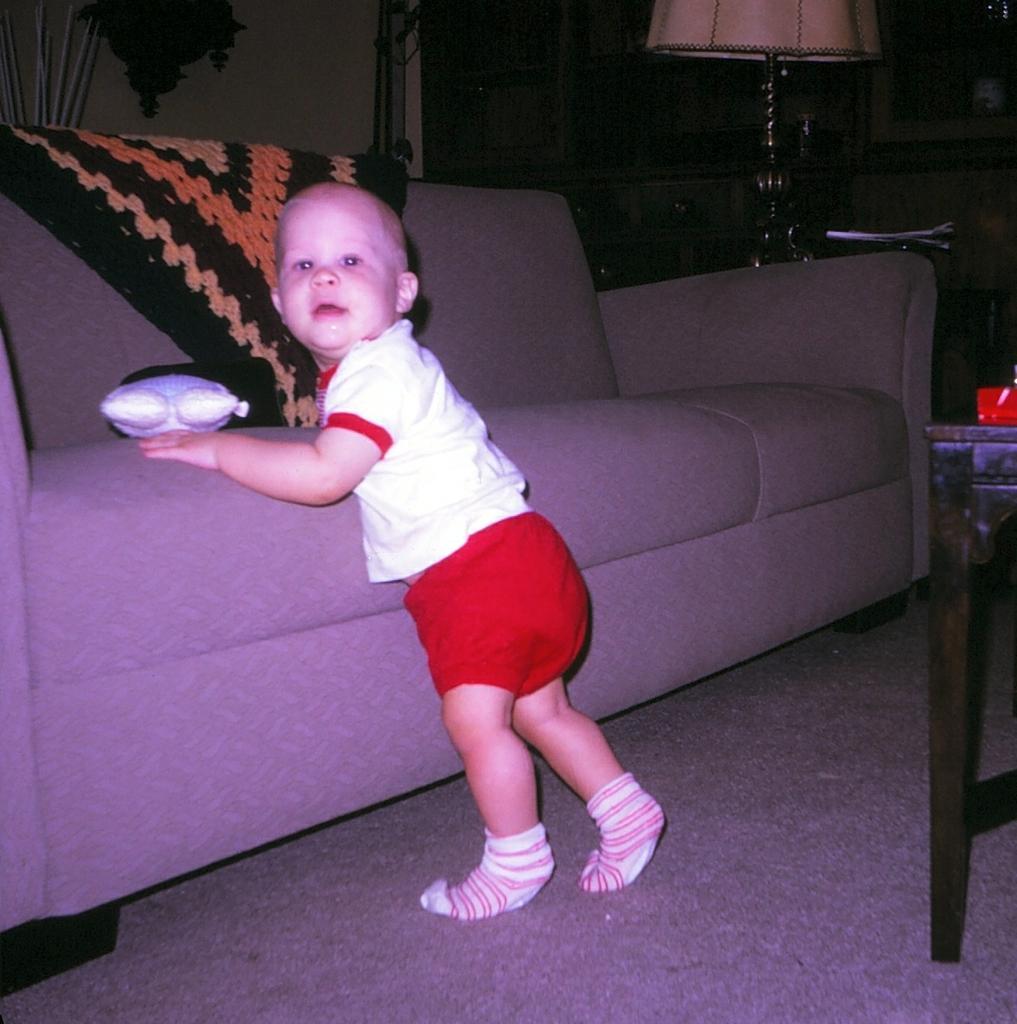In one or two sentences, can you explain what this image depicts? In this image there is a boy standing near the couch on the carpet, and there is a cloth and a toy on the couch, there is lamp, wall, cupboards, table, papers. 